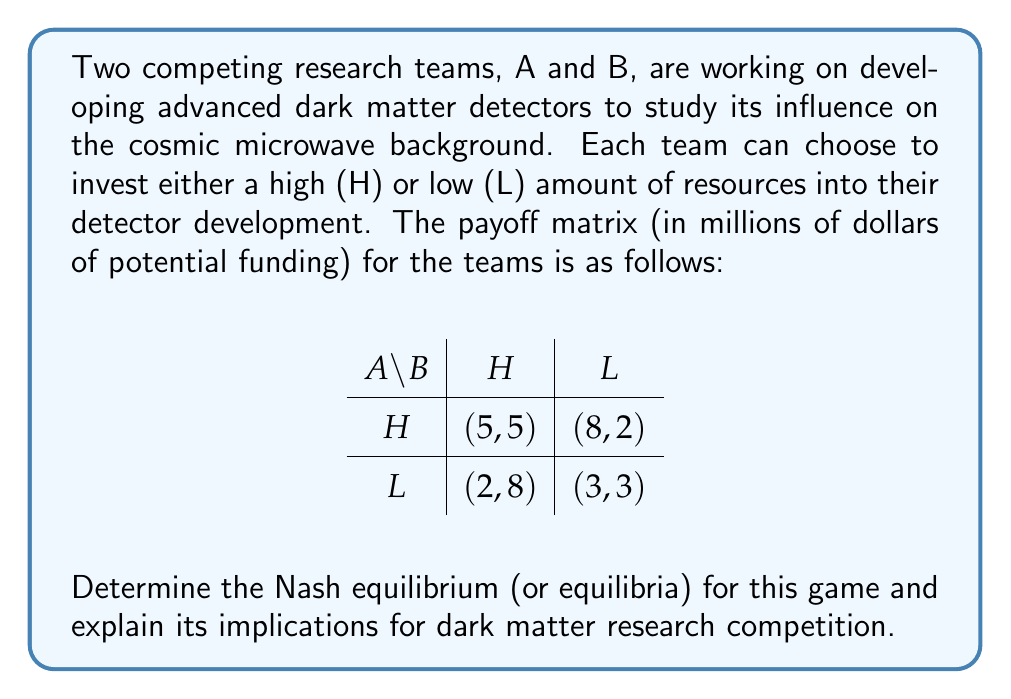Could you help me with this problem? To solve this problem, we need to analyze the strategic choices of both teams and find the Nash equilibrium. A Nash equilibrium is a set of strategies where no player can unilaterally improve their payoff by changing their strategy.

Step 1: Analyze Team A's best responses
- If B chooses H, A's best response is H (5 > 2)
- If B chooses L, A's best response is H (8 > 3)

Step 2: Analyze Team B's best responses
- If A chooses H, B's best response is H (5 > 2)
- If A chooses L, B's best response is H (8 > 3)

Step 3: Identify the Nash equilibrium
Since both teams have a dominant strategy of H (High investment), the Nash equilibrium is (H, H), resulting in payoffs of (5, 5).

Step 4: Interpret the results
This Nash equilibrium implies that both research teams will invest heavily in their dark matter detector development, regardless of the other team's choice. This leads to a competitive research environment where both teams are putting significant resources into their projects.

Implications for dark matter research:
1. Accelerated technological advancement: High investment from both teams may lead to faster development of advanced dark matter detectors.
2. Potential for breakthrough discoveries: Increased resources could improve the chances of detecting dark matter and its influence on the cosmic microwave background.
3. Resource allocation: The equilibrium suggests that funding agencies might need to prepare for high-cost research proposals in this field.
4. Collaboration vs. competition: The game highlights the competitive nature of research, but also raises questions about whether collaboration might lead to more efficient use of resources and faster scientific progress.
Answer: The Nash equilibrium for this game is (H, H), where both research teams choose to invest heavily in their dark matter detector development, resulting in payoffs of (5, 5) million dollars in potential funding for each team. 